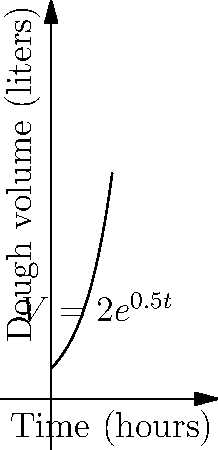As part of your Ramadan preparations, you're baking bread for the community iftar. The dough's volume growth follows the exponential function $V = 2e^{0.5t}$, where $V$ is the volume in liters and $t$ is time in hours. If you need the dough to triple in volume, how many hours should you let it rise? Let's approach this step-by-step:

1) The initial volume of the dough is when $t = 0$:
   $V = 2e^{0.5(0)} = 2$ liters

2) We want the volume to triple, so the final volume should be:
   $3 * 2 = 6$ liters

3) Now, we can set up the equation:
   $6 = 2e^{0.5t}$

4) Divide both sides by 2:
   $3 = e^{0.5t}$

5) Take the natural logarithm of both sides:
   $\ln(3) = \ln(e^{0.5t})$

6) Simplify the right side using the properties of logarithms:
   $\ln(3) = 0.5t$

7) Multiply both sides by 2:
   $2\ln(3) = t$

8) Calculate the final value:
   $t \approx 2.197$ hours

Therefore, you should let the dough rise for approximately 2.2 hours to triple in volume.
Answer: 2.2 hours 